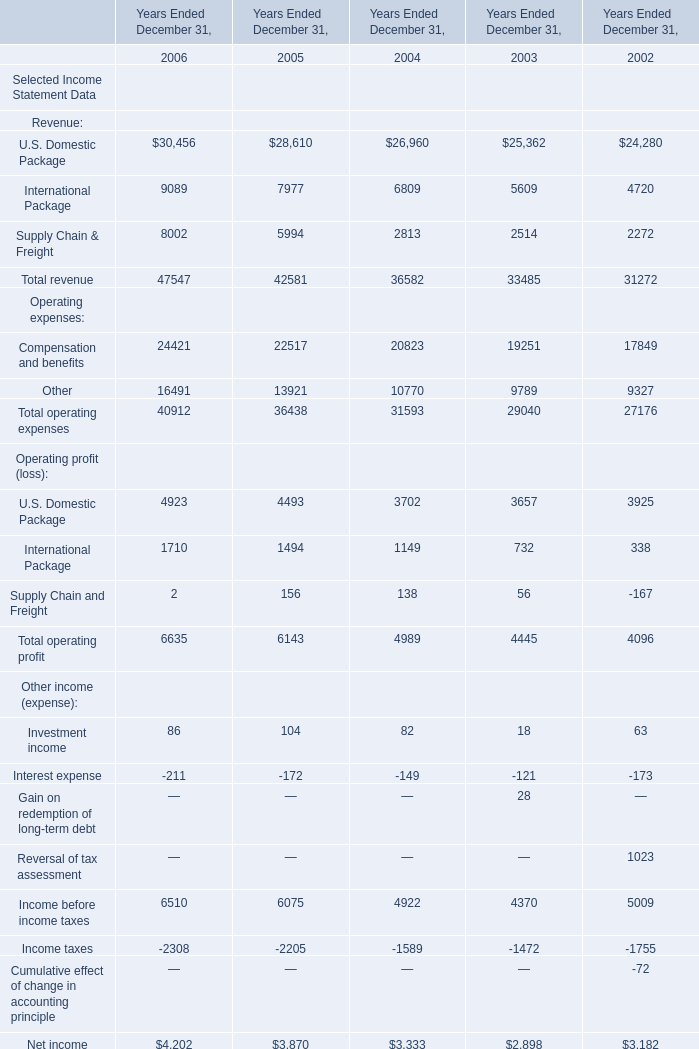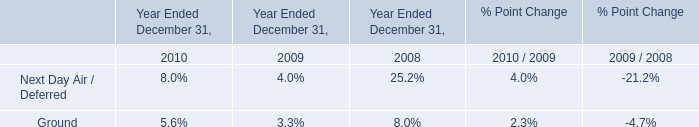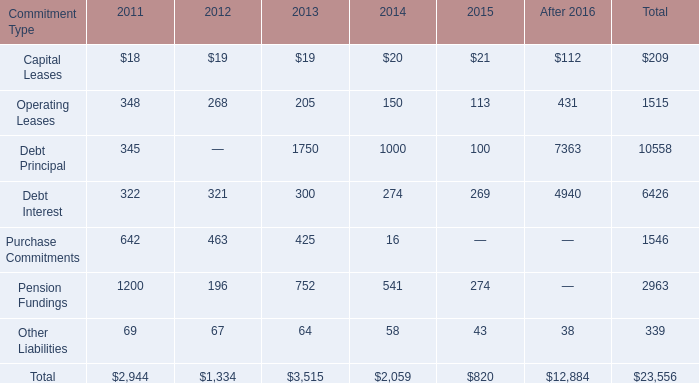What is the growing rate of Income before income taxes of Other income (expense): in the year with the most U.S. Domestic Package for Revenue? 
Computations: ((6510 - 6075) / 6510)
Answer: 0.06682. 